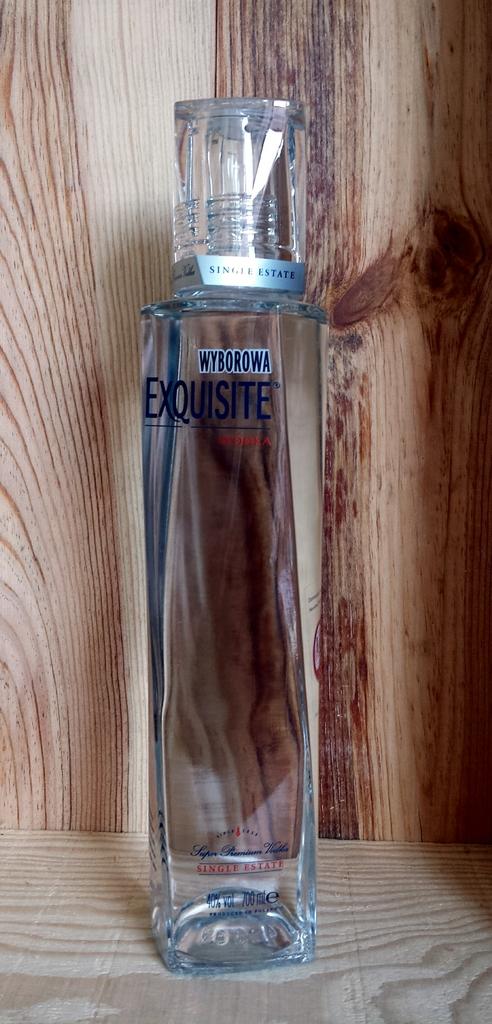What is the name of this cologne?
Provide a succinct answer. Exquisite. 